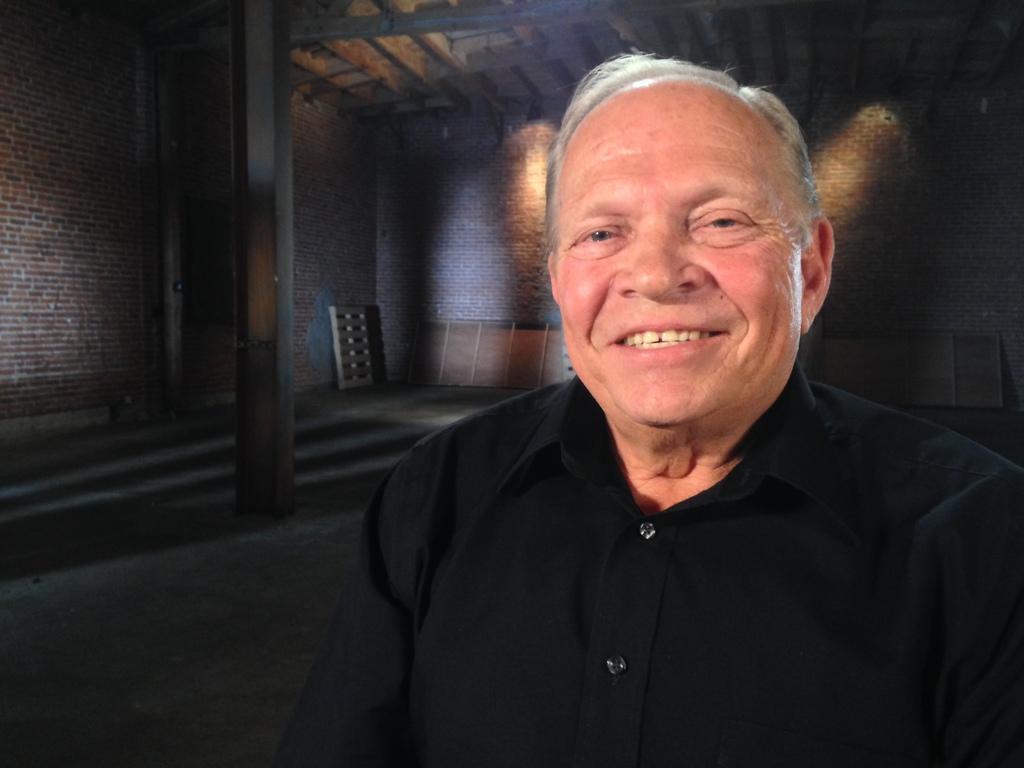Could you give a brief overview of what you see in this image? In this picture we can see a man smiling, he wore a black color shirt, in the background there is a wall, we can see a pillar here. 